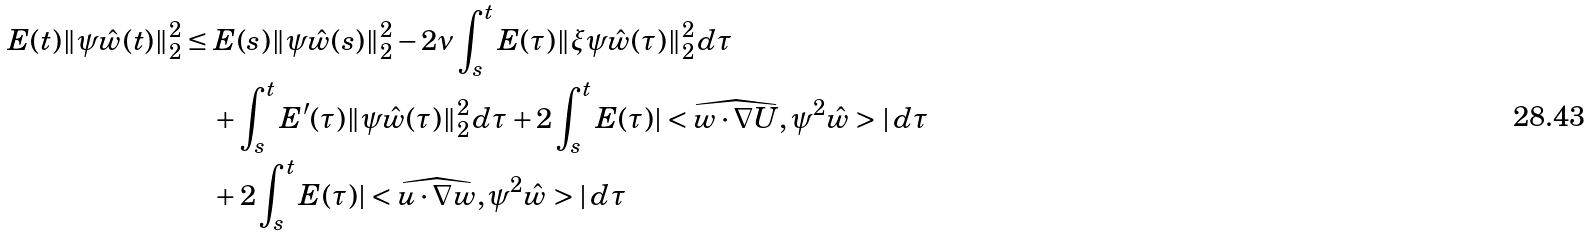<formula> <loc_0><loc_0><loc_500><loc_500>E ( t ) \| \psi \hat { w } ( t ) \| _ { 2 } ^ { 2 } & \leq E ( s ) \| \psi \hat { w } ( s ) \| _ { 2 } ^ { 2 } - 2 \nu \int _ { s } ^ { t } E ( \tau ) \| \xi \psi \hat { w } ( \tau ) \| _ { 2 } ^ { 2 } \, d \tau \\ & \quad + \int _ { s } ^ { t } E ^ { \prime } ( \tau ) \| \psi \hat { w } ( \tau ) \| _ { 2 } ^ { 2 } \, d \tau + 2 \int _ { s } ^ { t } E ( \tau ) | < \widehat { w \cdot \nabla U } , \psi ^ { 2 } \hat { w } > | \, d \tau \\ & \quad + 2 \int _ { s } ^ { t } E ( \tau ) | < \widehat { u \cdot \nabla w } , \psi ^ { 2 } \hat { w } > | \, d \tau</formula> 